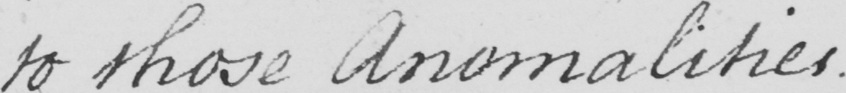Transcribe the text shown in this historical manuscript line. to those Anomalities . 